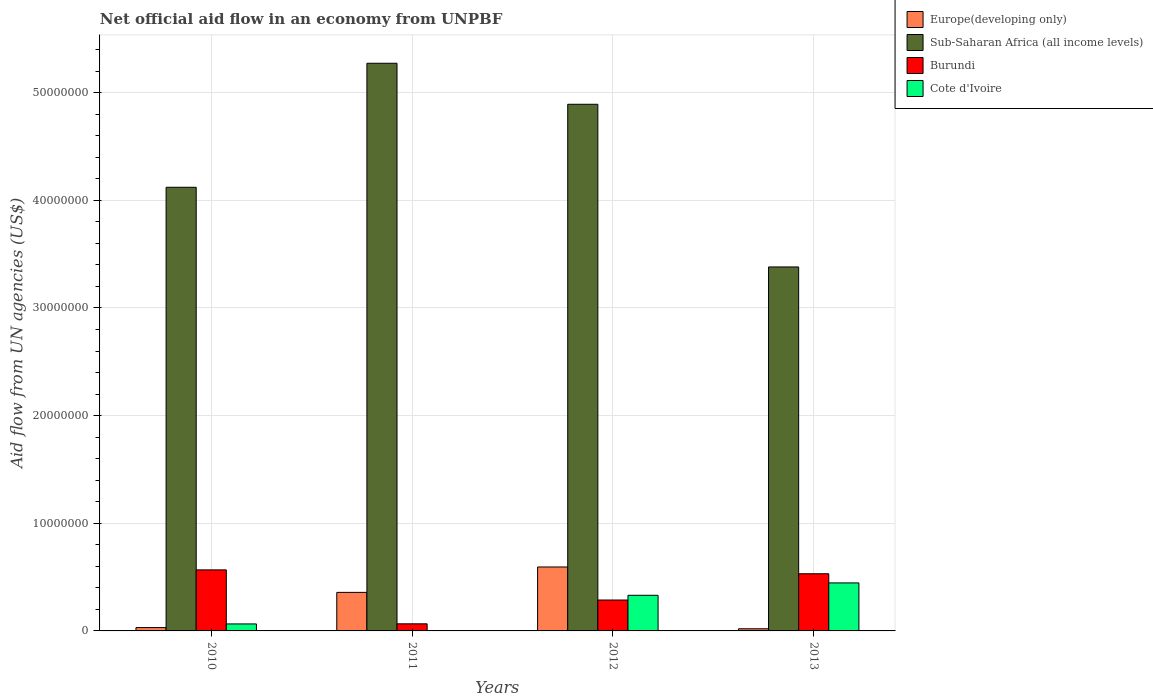How many different coloured bars are there?
Provide a succinct answer. 4. How many groups of bars are there?
Provide a short and direct response. 4. Are the number of bars per tick equal to the number of legend labels?
Your answer should be very brief. Yes. Are the number of bars on each tick of the X-axis equal?
Offer a very short reply. Yes. What is the label of the 2nd group of bars from the left?
Make the answer very short. 2011. What is the net official aid flow in Sub-Saharan Africa (all income levels) in 2010?
Keep it short and to the point. 4.12e+07. Across all years, what is the maximum net official aid flow in Sub-Saharan Africa (all income levels)?
Keep it short and to the point. 5.27e+07. Across all years, what is the minimum net official aid flow in Cote d'Ivoire?
Provide a succinct answer. 3.00e+04. What is the total net official aid flow in Sub-Saharan Africa (all income levels) in the graph?
Your answer should be very brief. 1.77e+08. What is the difference between the net official aid flow in Burundi in 2012 and that in 2013?
Offer a terse response. -2.44e+06. What is the difference between the net official aid flow in Burundi in 2011 and the net official aid flow in Sub-Saharan Africa (all income levels) in 2013?
Offer a terse response. -3.32e+07. What is the average net official aid flow in Cote d'Ivoire per year?
Make the answer very short. 2.11e+06. In the year 2012, what is the difference between the net official aid flow in Sub-Saharan Africa (all income levels) and net official aid flow in Europe(developing only)?
Your answer should be very brief. 4.30e+07. In how many years, is the net official aid flow in Burundi greater than 34000000 US$?
Your answer should be compact. 0. Is the difference between the net official aid flow in Sub-Saharan Africa (all income levels) in 2012 and 2013 greater than the difference between the net official aid flow in Europe(developing only) in 2012 and 2013?
Offer a very short reply. Yes. What is the difference between the highest and the second highest net official aid flow in Sub-Saharan Africa (all income levels)?
Make the answer very short. 3.81e+06. What is the difference between the highest and the lowest net official aid flow in Cote d'Ivoire?
Provide a succinct answer. 4.43e+06. In how many years, is the net official aid flow in Cote d'Ivoire greater than the average net official aid flow in Cote d'Ivoire taken over all years?
Your response must be concise. 2. What does the 1st bar from the left in 2013 represents?
Offer a terse response. Europe(developing only). What does the 4th bar from the right in 2013 represents?
Offer a very short reply. Europe(developing only). Is it the case that in every year, the sum of the net official aid flow in Europe(developing only) and net official aid flow in Burundi is greater than the net official aid flow in Sub-Saharan Africa (all income levels)?
Offer a terse response. No. Are all the bars in the graph horizontal?
Offer a very short reply. No. Does the graph contain grids?
Offer a very short reply. Yes. Where does the legend appear in the graph?
Offer a terse response. Top right. What is the title of the graph?
Offer a terse response. Net official aid flow in an economy from UNPBF. What is the label or title of the X-axis?
Provide a succinct answer. Years. What is the label or title of the Y-axis?
Provide a short and direct response. Aid flow from UN agencies (US$). What is the Aid flow from UN agencies (US$) of Sub-Saharan Africa (all income levels) in 2010?
Make the answer very short. 4.12e+07. What is the Aid flow from UN agencies (US$) in Burundi in 2010?
Give a very brief answer. 5.67e+06. What is the Aid flow from UN agencies (US$) of Cote d'Ivoire in 2010?
Ensure brevity in your answer.  6.50e+05. What is the Aid flow from UN agencies (US$) in Europe(developing only) in 2011?
Provide a succinct answer. 3.58e+06. What is the Aid flow from UN agencies (US$) of Sub-Saharan Africa (all income levels) in 2011?
Offer a terse response. 5.27e+07. What is the Aid flow from UN agencies (US$) of Burundi in 2011?
Provide a succinct answer. 6.60e+05. What is the Aid flow from UN agencies (US$) of Europe(developing only) in 2012?
Ensure brevity in your answer.  5.94e+06. What is the Aid flow from UN agencies (US$) in Sub-Saharan Africa (all income levels) in 2012?
Provide a short and direct response. 4.89e+07. What is the Aid flow from UN agencies (US$) in Burundi in 2012?
Your response must be concise. 2.87e+06. What is the Aid flow from UN agencies (US$) in Cote d'Ivoire in 2012?
Provide a short and direct response. 3.31e+06. What is the Aid flow from UN agencies (US$) of Europe(developing only) in 2013?
Give a very brief answer. 2.00e+05. What is the Aid flow from UN agencies (US$) of Sub-Saharan Africa (all income levels) in 2013?
Make the answer very short. 3.38e+07. What is the Aid flow from UN agencies (US$) of Burundi in 2013?
Your response must be concise. 5.31e+06. What is the Aid flow from UN agencies (US$) of Cote d'Ivoire in 2013?
Offer a very short reply. 4.46e+06. Across all years, what is the maximum Aid flow from UN agencies (US$) of Europe(developing only)?
Your answer should be very brief. 5.94e+06. Across all years, what is the maximum Aid flow from UN agencies (US$) of Sub-Saharan Africa (all income levels)?
Your response must be concise. 5.27e+07. Across all years, what is the maximum Aid flow from UN agencies (US$) in Burundi?
Give a very brief answer. 5.67e+06. Across all years, what is the maximum Aid flow from UN agencies (US$) in Cote d'Ivoire?
Keep it short and to the point. 4.46e+06. Across all years, what is the minimum Aid flow from UN agencies (US$) of Sub-Saharan Africa (all income levels)?
Make the answer very short. 3.38e+07. What is the total Aid flow from UN agencies (US$) in Europe(developing only) in the graph?
Ensure brevity in your answer.  1.00e+07. What is the total Aid flow from UN agencies (US$) of Sub-Saharan Africa (all income levels) in the graph?
Keep it short and to the point. 1.77e+08. What is the total Aid flow from UN agencies (US$) in Burundi in the graph?
Provide a short and direct response. 1.45e+07. What is the total Aid flow from UN agencies (US$) of Cote d'Ivoire in the graph?
Provide a short and direct response. 8.45e+06. What is the difference between the Aid flow from UN agencies (US$) of Europe(developing only) in 2010 and that in 2011?
Provide a short and direct response. -3.27e+06. What is the difference between the Aid flow from UN agencies (US$) in Sub-Saharan Africa (all income levels) in 2010 and that in 2011?
Offer a terse response. -1.15e+07. What is the difference between the Aid flow from UN agencies (US$) in Burundi in 2010 and that in 2011?
Your answer should be very brief. 5.01e+06. What is the difference between the Aid flow from UN agencies (US$) of Cote d'Ivoire in 2010 and that in 2011?
Make the answer very short. 6.20e+05. What is the difference between the Aid flow from UN agencies (US$) of Europe(developing only) in 2010 and that in 2012?
Offer a very short reply. -5.63e+06. What is the difference between the Aid flow from UN agencies (US$) in Sub-Saharan Africa (all income levels) in 2010 and that in 2012?
Offer a very short reply. -7.71e+06. What is the difference between the Aid flow from UN agencies (US$) in Burundi in 2010 and that in 2012?
Make the answer very short. 2.80e+06. What is the difference between the Aid flow from UN agencies (US$) in Cote d'Ivoire in 2010 and that in 2012?
Ensure brevity in your answer.  -2.66e+06. What is the difference between the Aid flow from UN agencies (US$) in Europe(developing only) in 2010 and that in 2013?
Provide a short and direct response. 1.10e+05. What is the difference between the Aid flow from UN agencies (US$) in Sub-Saharan Africa (all income levels) in 2010 and that in 2013?
Offer a very short reply. 7.40e+06. What is the difference between the Aid flow from UN agencies (US$) of Cote d'Ivoire in 2010 and that in 2013?
Provide a succinct answer. -3.81e+06. What is the difference between the Aid flow from UN agencies (US$) of Europe(developing only) in 2011 and that in 2012?
Keep it short and to the point. -2.36e+06. What is the difference between the Aid flow from UN agencies (US$) of Sub-Saharan Africa (all income levels) in 2011 and that in 2012?
Your answer should be very brief. 3.81e+06. What is the difference between the Aid flow from UN agencies (US$) in Burundi in 2011 and that in 2012?
Your response must be concise. -2.21e+06. What is the difference between the Aid flow from UN agencies (US$) in Cote d'Ivoire in 2011 and that in 2012?
Your response must be concise. -3.28e+06. What is the difference between the Aid flow from UN agencies (US$) in Europe(developing only) in 2011 and that in 2013?
Provide a succinct answer. 3.38e+06. What is the difference between the Aid flow from UN agencies (US$) in Sub-Saharan Africa (all income levels) in 2011 and that in 2013?
Offer a very short reply. 1.89e+07. What is the difference between the Aid flow from UN agencies (US$) in Burundi in 2011 and that in 2013?
Make the answer very short. -4.65e+06. What is the difference between the Aid flow from UN agencies (US$) of Cote d'Ivoire in 2011 and that in 2013?
Provide a succinct answer. -4.43e+06. What is the difference between the Aid flow from UN agencies (US$) of Europe(developing only) in 2012 and that in 2013?
Your response must be concise. 5.74e+06. What is the difference between the Aid flow from UN agencies (US$) of Sub-Saharan Africa (all income levels) in 2012 and that in 2013?
Make the answer very short. 1.51e+07. What is the difference between the Aid flow from UN agencies (US$) of Burundi in 2012 and that in 2013?
Your answer should be compact. -2.44e+06. What is the difference between the Aid flow from UN agencies (US$) of Cote d'Ivoire in 2012 and that in 2013?
Ensure brevity in your answer.  -1.15e+06. What is the difference between the Aid flow from UN agencies (US$) of Europe(developing only) in 2010 and the Aid flow from UN agencies (US$) of Sub-Saharan Africa (all income levels) in 2011?
Offer a terse response. -5.24e+07. What is the difference between the Aid flow from UN agencies (US$) in Europe(developing only) in 2010 and the Aid flow from UN agencies (US$) in Burundi in 2011?
Make the answer very short. -3.50e+05. What is the difference between the Aid flow from UN agencies (US$) of Sub-Saharan Africa (all income levels) in 2010 and the Aid flow from UN agencies (US$) of Burundi in 2011?
Your response must be concise. 4.06e+07. What is the difference between the Aid flow from UN agencies (US$) of Sub-Saharan Africa (all income levels) in 2010 and the Aid flow from UN agencies (US$) of Cote d'Ivoire in 2011?
Your answer should be very brief. 4.12e+07. What is the difference between the Aid flow from UN agencies (US$) of Burundi in 2010 and the Aid flow from UN agencies (US$) of Cote d'Ivoire in 2011?
Make the answer very short. 5.64e+06. What is the difference between the Aid flow from UN agencies (US$) of Europe(developing only) in 2010 and the Aid flow from UN agencies (US$) of Sub-Saharan Africa (all income levels) in 2012?
Keep it short and to the point. -4.86e+07. What is the difference between the Aid flow from UN agencies (US$) in Europe(developing only) in 2010 and the Aid flow from UN agencies (US$) in Burundi in 2012?
Offer a very short reply. -2.56e+06. What is the difference between the Aid flow from UN agencies (US$) in Europe(developing only) in 2010 and the Aid flow from UN agencies (US$) in Cote d'Ivoire in 2012?
Offer a very short reply. -3.00e+06. What is the difference between the Aid flow from UN agencies (US$) of Sub-Saharan Africa (all income levels) in 2010 and the Aid flow from UN agencies (US$) of Burundi in 2012?
Keep it short and to the point. 3.83e+07. What is the difference between the Aid flow from UN agencies (US$) in Sub-Saharan Africa (all income levels) in 2010 and the Aid flow from UN agencies (US$) in Cote d'Ivoire in 2012?
Your answer should be very brief. 3.79e+07. What is the difference between the Aid flow from UN agencies (US$) in Burundi in 2010 and the Aid flow from UN agencies (US$) in Cote d'Ivoire in 2012?
Offer a very short reply. 2.36e+06. What is the difference between the Aid flow from UN agencies (US$) in Europe(developing only) in 2010 and the Aid flow from UN agencies (US$) in Sub-Saharan Africa (all income levels) in 2013?
Provide a succinct answer. -3.35e+07. What is the difference between the Aid flow from UN agencies (US$) in Europe(developing only) in 2010 and the Aid flow from UN agencies (US$) in Burundi in 2013?
Provide a short and direct response. -5.00e+06. What is the difference between the Aid flow from UN agencies (US$) in Europe(developing only) in 2010 and the Aid flow from UN agencies (US$) in Cote d'Ivoire in 2013?
Give a very brief answer. -4.15e+06. What is the difference between the Aid flow from UN agencies (US$) in Sub-Saharan Africa (all income levels) in 2010 and the Aid flow from UN agencies (US$) in Burundi in 2013?
Provide a succinct answer. 3.59e+07. What is the difference between the Aid flow from UN agencies (US$) of Sub-Saharan Africa (all income levels) in 2010 and the Aid flow from UN agencies (US$) of Cote d'Ivoire in 2013?
Give a very brief answer. 3.68e+07. What is the difference between the Aid flow from UN agencies (US$) in Burundi in 2010 and the Aid flow from UN agencies (US$) in Cote d'Ivoire in 2013?
Your answer should be compact. 1.21e+06. What is the difference between the Aid flow from UN agencies (US$) of Europe(developing only) in 2011 and the Aid flow from UN agencies (US$) of Sub-Saharan Africa (all income levels) in 2012?
Your answer should be very brief. -4.53e+07. What is the difference between the Aid flow from UN agencies (US$) in Europe(developing only) in 2011 and the Aid flow from UN agencies (US$) in Burundi in 2012?
Offer a terse response. 7.10e+05. What is the difference between the Aid flow from UN agencies (US$) of Europe(developing only) in 2011 and the Aid flow from UN agencies (US$) of Cote d'Ivoire in 2012?
Your answer should be very brief. 2.70e+05. What is the difference between the Aid flow from UN agencies (US$) of Sub-Saharan Africa (all income levels) in 2011 and the Aid flow from UN agencies (US$) of Burundi in 2012?
Offer a terse response. 4.99e+07. What is the difference between the Aid flow from UN agencies (US$) of Sub-Saharan Africa (all income levels) in 2011 and the Aid flow from UN agencies (US$) of Cote d'Ivoire in 2012?
Your answer should be very brief. 4.94e+07. What is the difference between the Aid flow from UN agencies (US$) in Burundi in 2011 and the Aid flow from UN agencies (US$) in Cote d'Ivoire in 2012?
Make the answer very short. -2.65e+06. What is the difference between the Aid flow from UN agencies (US$) in Europe(developing only) in 2011 and the Aid flow from UN agencies (US$) in Sub-Saharan Africa (all income levels) in 2013?
Provide a succinct answer. -3.02e+07. What is the difference between the Aid flow from UN agencies (US$) of Europe(developing only) in 2011 and the Aid flow from UN agencies (US$) of Burundi in 2013?
Offer a terse response. -1.73e+06. What is the difference between the Aid flow from UN agencies (US$) of Europe(developing only) in 2011 and the Aid flow from UN agencies (US$) of Cote d'Ivoire in 2013?
Provide a short and direct response. -8.80e+05. What is the difference between the Aid flow from UN agencies (US$) of Sub-Saharan Africa (all income levels) in 2011 and the Aid flow from UN agencies (US$) of Burundi in 2013?
Provide a succinct answer. 4.74e+07. What is the difference between the Aid flow from UN agencies (US$) of Sub-Saharan Africa (all income levels) in 2011 and the Aid flow from UN agencies (US$) of Cote d'Ivoire in 2013?
Offer a very short reply. 4.83e+07. What is the difference between the Aid flow from UN agencies (US$) in Burundi in 2011 and the Aid flow from UN agencies (US$) in Cote d'Ivoire in 2013?
Your response must be concise. -3.80e+06. What is the difference between the Aid flow from UN agencies (US$) in Europe(developing only) in 2012 and the Aid flow from UN agencies (US$) in Sub-Saharan Africa (all income levels) in 2013?
Make the answer very short. -2.79e+07. What is the difference between the Aid flow from UN agencies (US$) of Europe(developing only) in 2012 and the Aid flow from UN agencies (US$) of Burundi in 2013?
Ensure brevity in your answer.  6.30e+05. What is the difference between the Aid flow from UN agencies (US$) of Europe(developing only) in 2012 and the Aid flow from UN agencies (US$) of Cote d'Ivoire in 2013?
Your response must be concise. 1.48e+06. What is the difference between the Aid flow from UN agencies (US$) in Sub-Saharan Africa (all income levels) in 2012 and the Aid flow from UN agencies (US$) in Burundi in 2013?
Keep it short and to the point. 4.36e+07. What is the difference between the Aid flow from UN agencies (US$) in Sub-Saharan Africa (all income levels) in 2012 and the Aid flow from UN agencies (US$) in Cote d'Ivoire in 2013?
Your answer should be very brief. 4.45e+07. What is the difference between the Aid flow from UN agencies (US$) of Burundi in 2012 and the Aid flow from UN agencies (US$) of Cote d'Ivoire in 2013?
Provide a succinct answer. -1.59e+06. What is the average Aid flow from UN agencies (US$) in Europe(developing only) per year?
Ensure brevity in your answer.  2.51e+06. What is the average Aid flow from UN agencies (US$) of Sub-Saharan Africa (all income levels) per year?
Your response must be concise. 4.42e+07. What is the average Aid flow from UN agencies (US$) in Burundi per year?
Ensure brevity in your answer.  3.63e+06. What is the average Aid flow from UN agencies (US$) in Cote d'Ivoire per year?
Your response must be concise. 2.11e+06. In the year 2010, what is the difference between the Aid flow from UN agencies (US$) in Europe(developing only) and Aid flow from UN agencies (US$) in Sub-Saharan Africa (all income levels)?
Give a very brief answer. -4.09e+07. In the year 2010, what is the difference between the Aid flow from UN agencies (US$) of Europe(developing only) and Aid flow from UN agencies (US$) of Burundi?
Provide a short and direct response. -5.36e+06. In the year 2010, what is the difference between the Aid flow from UN agencies (US$) in Sub-Saharan Africa (all income levels) and Aid flow from UN agencies (US$) in Burundi?
Your answer should be compact. 3.55e+07. In the year 2010, what is the difference between the Aid flow from UN agencies (US$) in Sub-Saharan Africa (all income levels) and Aid flow from UN agencies (US$) in Cote d'Ivoire?
Your answer should be very brief. 4.06e+07. In the year 2010, what is the difference between the Aid flow from UN agencies (US$) of Burundi and Aid flow from UN agencies (US$) of Cote d'Ivoire?
Provide a short and direct response. 5.02e+06. In the year 2011, what is the difference between the Aid flow from UN agencies (US$) in Europe(developing only) and Aid flow from UN agencies (US$) in Sub-Saharan Africa (all income levels)?
Offer a terse response. -4.92e+07. In the year 2011, what is the difference between the Aid flow from UN agencies (US$) in Europe(developing only) and Aid flow from UN agencies (US$) in Burundi?
Offer a very short reply. 2.92e+06. In the year 2011, what is the difference between the Aid flow from UN agencies (US$) of Europe(developing only) and Aid flow from UN agencies (US$) of Cote d'Ivoire?
Make the answer very short. 3.55e+06. In the year 2011, what is the difference between the Aid flow from UN agencies (US$) of Sub-Saharan Africa (all income levels) and Aid flow from UN agencies (US$) of Burundi?
Give a very brief answer. 5.21e+07. In the year 2011, what is the difference between the Aid flow from UN agencies (US$) in Sub-Saharan Africa (all income levels) and Aid flow from UN agencies (US$) in Cote d'Ivoire?
Provide a short and direct response. 5.27e+07. In the year 2011, what is the difference between the Aid flow from UN agencies (US$) of Burundi and Aid flow from UN agencies (US$) of Cote d'Ivoire?
Ensure brevity in your answer.  6.30e+05. In the year 2012, what is the difference between the Aid flow from UN agencies (US$) in Europe(developing only) and Aid flow from UN agencies (US$) in Sub-Saharan Africa (all income levels)?
Your response must be concise. -4.30e+07. In the year 2012, what is the difference between the Aid flow from UN agencies (US$) in Europe(developing only) and Aid flow from UN agencies (US$) in Burundi?
Keep it short and to the point. 3.07e+06. In the year 2012, what is the difference between the Aid flow from UN agencies (US$) of Europe(developing only) and Aid flow from UN agencies (US$) of Cote d'Ivoire?
Offer a very short reply. 2.63e+06. In the year 2012, what is the difference between the Aid flow from UN agencies (US$) of Sub-Saharan Africa (all income levels) and Aid flow from UN agencies (US$) of Burundi?
Your answer should be compact. 4.60e+07. In the year 2012, what is the difference between the Aid flow from UN agencies (US$) in Sub-Saharan Africa (all income levels) and Aid flow from UN agencies (US$) in Cote d'Ivoire?
Give a very brief answer. 4.56e+07. In the year 2012, what is the difference between the Aid flow from UN agencies (US$) of Burundi and Aid flow from UN agencies (US$) of Cote d'Ivoire?
Your answer should be compact. -4.40e+05. In the year 2013, what is the difference between the Aid flow from UN agencies (US$) of Europe(developing only) and Aid flow from UN agencies (US$) of Sub-Saharan Africa (all income levels)?
Your answer should be compact. -3.36e+07. In the year 2013, what is the difference between the Aid flow from UN agencies (US$) in Europe(developing only) and Aid flow from UN agencies (US$) in Burundi?
Your response must be concise. -5.11e+06. In the year 2013, what is the difference between the Aid flow from UN agencies (US$) of Europe(developing only) and Aid flow from UN agencies (US$) of Cote d'Ivoire?
Offer a very short reply. -4.26e+06. In the year 2013, what is the difference between the Aid flow from UN agencies (US$) in Sub-Saharan Africa (all income levels) and Aid flow from UN agencies (US$) in Burundi?
Offer a very short reply. 2.85e+07. In the year 2013, what is the difference between the Aid flow from UN agencies (US$) of Sub-Saharan Africa (all income levels) and Aid flow from UN agencies (US$) of Cote d'Ivoire?
Give a very brief answer. 2.94e+07. In the year 2013, what is the difference between the Aid flow from UN agencies (US$) in Burundi and Aid flow from UN agencies (US$) in Cote d'Ivoire?
Make the answer very short. 8.50e+05. What is the ratio of the Aid flow from UN agencies (US$) of Europe(developing only) in 2010 to that in 2011?
Make the answer very short. 0.09. What is the ratio of the Aid flow from UN agencies (US$) of Sub-Saharan Africa (all income levels) in 2010 to that in 2011?
Your answer should be compact. 0.78. What is the ratio of the Aid flow from UN agencies (US$) of Burundi in 2010 to that in 2011?
Keep it short and to the point. 8.59. What is the ratio of the Aid flow from UN agencies (US$) in Cote d'Ivoire in 2010 to that in 2011?
Your answer should be very brief. 21.67. What is the ratio of the Aid flow from UN agencies (US$) in Europe(developing only) in 2010 to that in 2012?
Keep it short and to the point. 0.05. What is the ratio of the Aid flow from UN agencies (US$) in Sub-Saharan Africa (all income levels) in 2010 to that in 2012?
Ensure brevity in your answer.  0.84. What is the ratio of the Aid flow from UN agencies (US$) of Burundi in 2010 to that in 2012?
Your response must be concise. 1.98. What is the ratio of the Aid flow from UN agencies (US$) in Cote d'Ivoire in 2010 to that in 2012?
Provide a succinct answer. 0.2. What is the ratio of the Aid flow from UN agencies (US$) in Europe(developing only) in 2010 to that in 2013?
Your answer should be very brief. 1.55. What is the ratio of the Aid flow from UN agencies (US$) of Sub-Saharan Africa (all income levels) in 2010 to that in 2013?
Give a very brief answer. 1.22. What is the ratio of the Aid flow from UN agencies (US$) of Burundi in 2010 to that in 2013?
Ensure brevity in your answer.  1.07. What is the ratio of the Aid flow from UN agencies (US$) in Cote d'Ivoire in 2010 to that in 2013?
Your answer should be very brief. 0.15. What is the ratio of the Aid flow from UN agencies (US$) in Europe(developing only) in 2011 to that in 2012?
Offer a terse response. 0.6. What is the ratio of the Aid flow from UN agencies (US$) of Sub-Saharan Africa (all income levels) in 2011 to that in 2012?
Ensure brevity in your answer.  1.08. What is the ratio of the Aid flow from UN agencies (US$) of Burundi in 2011 to that in 2012?
Provide a succinct answer. 0.23. What is the ratio of the Aid flow from UN agencies (US$) in Cote d'Ivoire in 2011 to that in 2012?
Keep it short and to the point. 0.01. What is the ratio of the Aid flow from UN agencies (US$) of Europe(developing only) in 2011 to that in 2013?
Give a very brief answer. 17.9. What is the ratio of the Aid flow from UN agencies (US$) of Sub-Saharan Africa (all income levels) in 2011 to that in 2013?
Offer a terse response. 1.56. What is the ratio of the Aid flow from UN agencies (US$) of Burundi in 2011 to that in 2013?
Offer a very short reply. 0.12. What is the ratio of the Aid flow from UN agencies (US$) in Cote d'Ivoire in 2011 to that in 2013?
Give a very brief answer. 0.01. What is the ratio of the Aid flow from UN agencies (US$) of Europe(developing only) in 2012 to that in 2013?
Make the answer very short. 29.7. What is the ratio of the Aid flow from UN agencies (US$) in Sub-Saharan Africa (all income levels) in 2012 to that in 2013?
Provide a succinct answer. 1.45. What is the ratio of the Aid flow from UN agencies (US$) of Burundi in 2012 to that in 2013?
Ensure brevity in your answer.  0.54. What is the ratio of the Aid flow from UN agencies (US$) in Cote d'Ivoire in 2012 to that in 2013?
Your response must be concise. 0.74. What is the difference between the highest and the second highest Aid flow from UN agencies (US$) in Europe(developing only)?
Offer a terse response. 2.36e+06. What is the difference between the highest and the second highest Aid flow from UN agencies (US$) of Sub-Saharan Africa (all income levels)?
Provide a succinct answer. 3.81e+06. What is the difference between the highest and the second highest Aid flow from UN agencies (US$) in Cote d'Ivoire?
Provide a short and direct response. 1.15e+06. What is the difference between the highest and the lowest Aid flow from UN agencies (US$) of Europe(developing only)?
Provide a short and direct response. 5.74e+06. What is the difference between the highest and the lowest Aid flow from UN agencies (US$) of Sub-Saharan Africa (all income levels)?
Your answer should be very brief. 1.89e+07. What is the difference between the highest and the lowest Aid flow from UN agencies (US$) of Burundi?
Keep it short and to the point. 5.01e+06. What is the difference between the highest and the lowest Aid flow from UN agencies (US$) of Cote d'Ivoire?
Provide a short and direct response. 4.43e+06. 